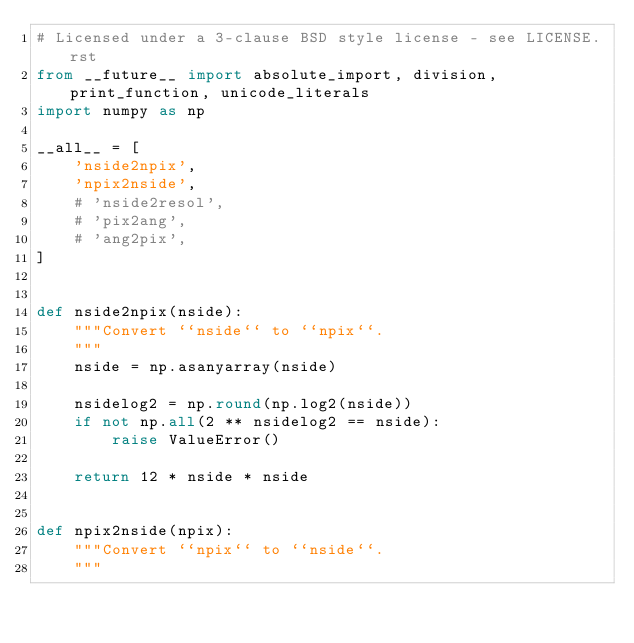Convert code to text. <code><loc_0><loc_0><loc_500><loc_500><_Python_># Licensed under a 3-clause BSD style license - see LICENSE.rst
from __future__ import absolute_import, division, print_function, unicode_literals
import numpy as np

__all__ = [
    'nside2npix',
    'npix2nside',
    # 'nside2resol',
    # 'pix2ang',
    # 'ang2pix',
]


def nside2npix(nside):
    """Convert ``nside`` to ``npix``.
    """
    nside = np.asanyarray(nside)

    nsidelog2 = np.round(np.log2(nside))
    if not np.all(2 ** nsidelog2 == nside):
        raise ValueError()

    return 12 * nside * nside


def npix2nside(npix):
    """Convert ``npix`` to ``nside``.
    """</code> 